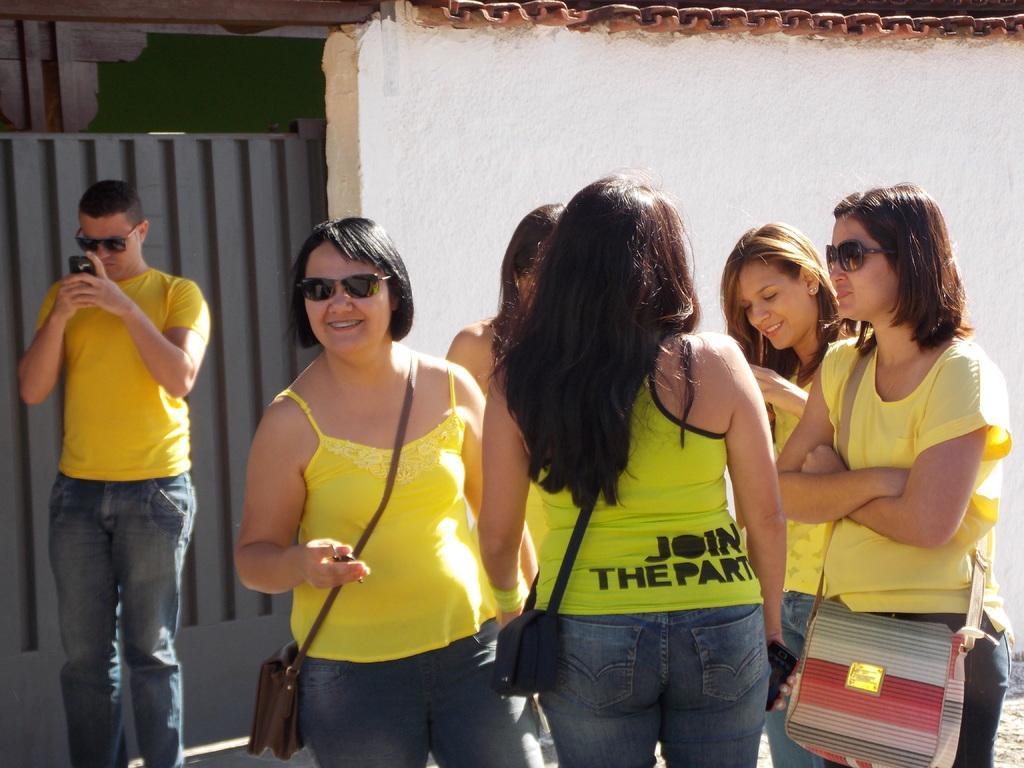Could you give a brief overview of what you see in this image? In this picture I can see group of people standing, there is a person holding an object, and in the background there is a wall and a gate. 